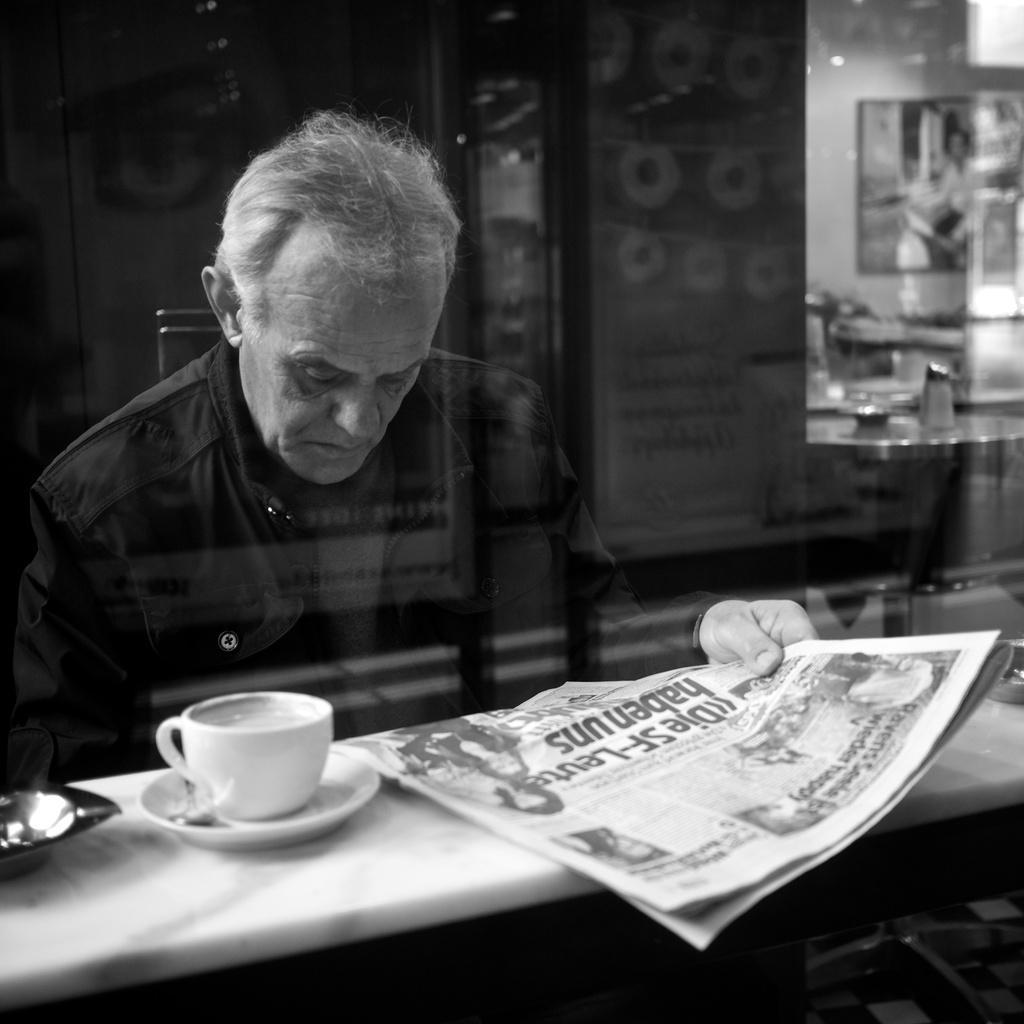How would you summarize this image in a sentence or two? The person wearing black dress is holding a newspaper in his hand which is placed on the table and there is a cup beside it. 